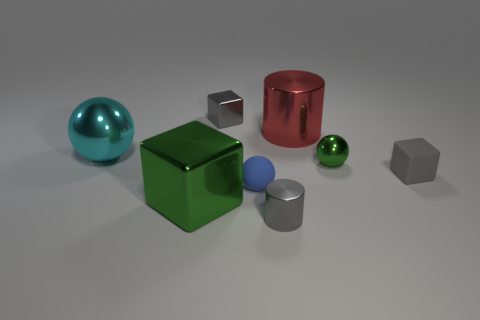The large object that is in front of the large metal cylinder and behind the green cube has what shape?
Give a very brief answer. Sphere. There is a tiny gray cube on the right side of the large shiny cylinder left of the gray matte object; how many big red things are to the right of it?
Provide a short and direct response. 0. There is a green metallic object that is the same shape as the tiny blue object; what is its size?
Provide a short and direct response. Small. Is there anything else that is the same size as the rubber block?
Provide a succinct answer. Yes. Is the material of the blue object in front of the big red shiny cylinder the same as the small gray cylinder?
Provide a short and direct response. No. There is another shiny thing that is the same shape as the tiny green thing; what is its color?
Your response must be concise. Cyan. What number of other things are there of the same color as the small matte cube?
Your response must be concise. 2. Do the small metallic object that is to the left of the matte sphere and the green shiny object that is left of the gray metallic block have the same shape?
Ensure brevity in your answer.  Yes. What number of cubes are either large metal objects or small green things?
Give a very brief answer. 1. Is the number of small things that are to the left of the red metal cylinder less than the number of large objects?
Your answer should be compact. No. 